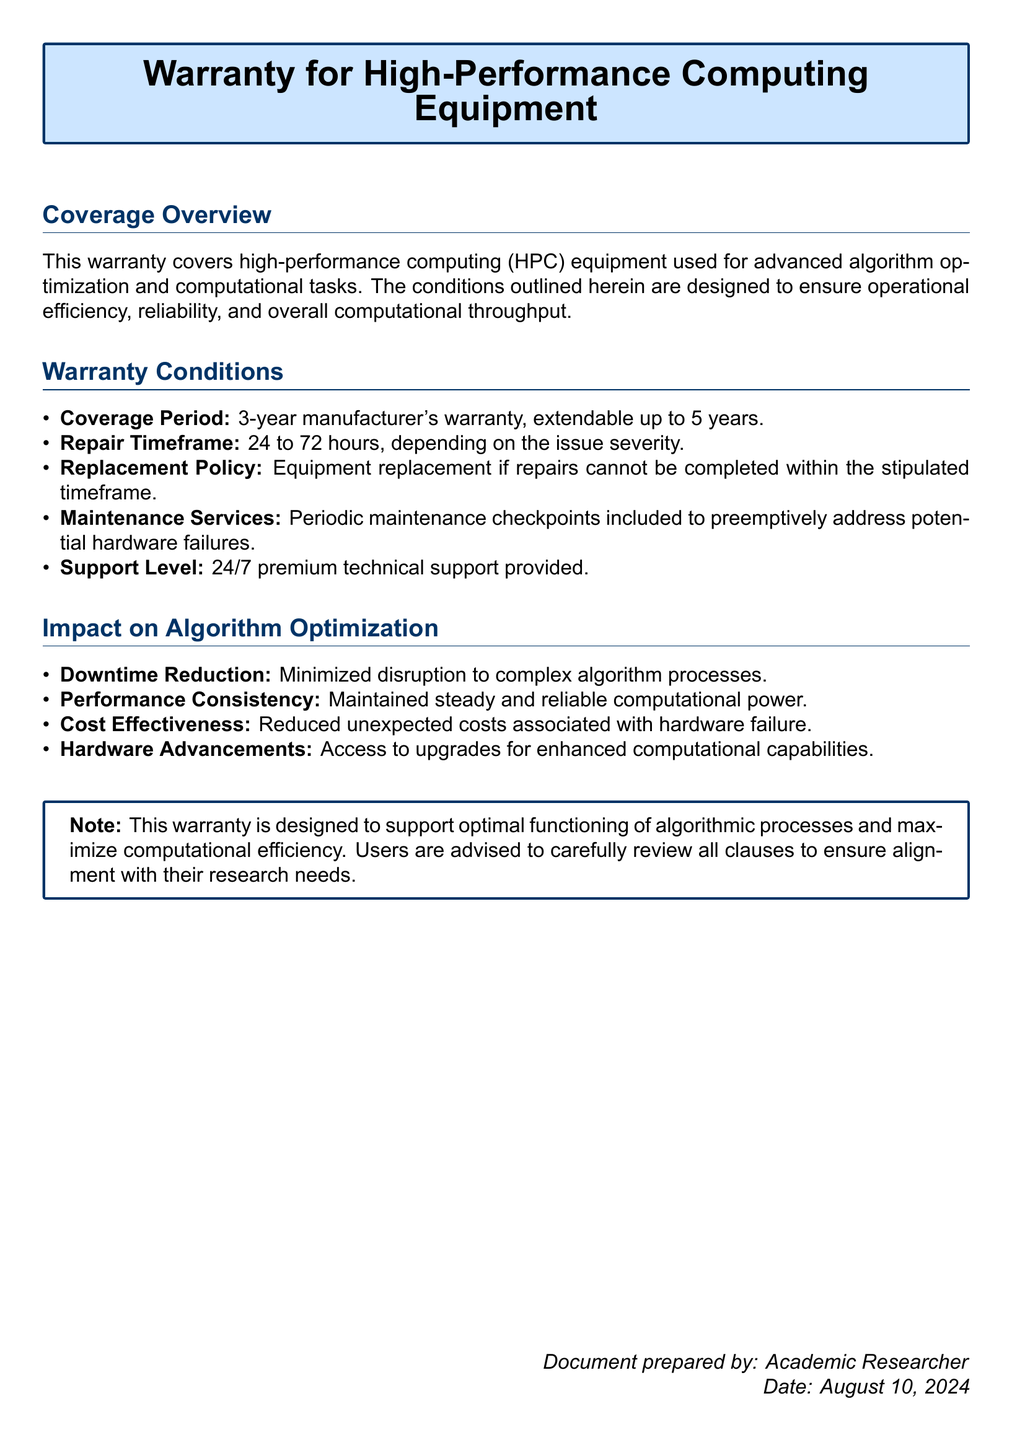What is the coverage period of the warranty? The coverage period is explicitly stated in the document as a 3-year manufacturer's warranty, extendable up to 5 years.
Answer: 3 years What is the repair timeframe specified in the warranty? The warranty outlines the repair timeframe as being between 24 to 72 hours, based on issue severity.
Answer: 24 to 72 hours What type of support is provided under this warranty? The document specifies that 24/7 premium technical support is included as part of the warranty services.
Answer: 24/7 premium technical support What is one way the warranty reduces downtime? The document mentions that the warranty minimizes disruption to complex algorithm processes, indicating a reduction in downtime.
Answer: Minimized disruption How long can the warranty be extended? The document states that the manufacturer's warranty can be extended up to 5 years.
Answer: 5 years What is the note at the end of the document advising users to do? The note advises users to carefully review all clauses to ensure alignment with their research needs.
Answer: Review all clauses What is one impact of the warranty on algorithm optimization? The document lists several impacts, including performance consistency, indicating that it helps maintain steady and reliable computational power.
Answer: Performance consistency What action is taken if repairs cannot be completed within the timeframe? The document specifies that equipment replacement will occur if repairs cannot be completed within the stipulated timeframe.
Answer: Equipment replacement What type of equipment does the warranty cover? The warranty specifically covers high-performance computing (HPC) equipment used for advanced algorithm optimization and computational tasks.
Answer: High-performance computing equipment 